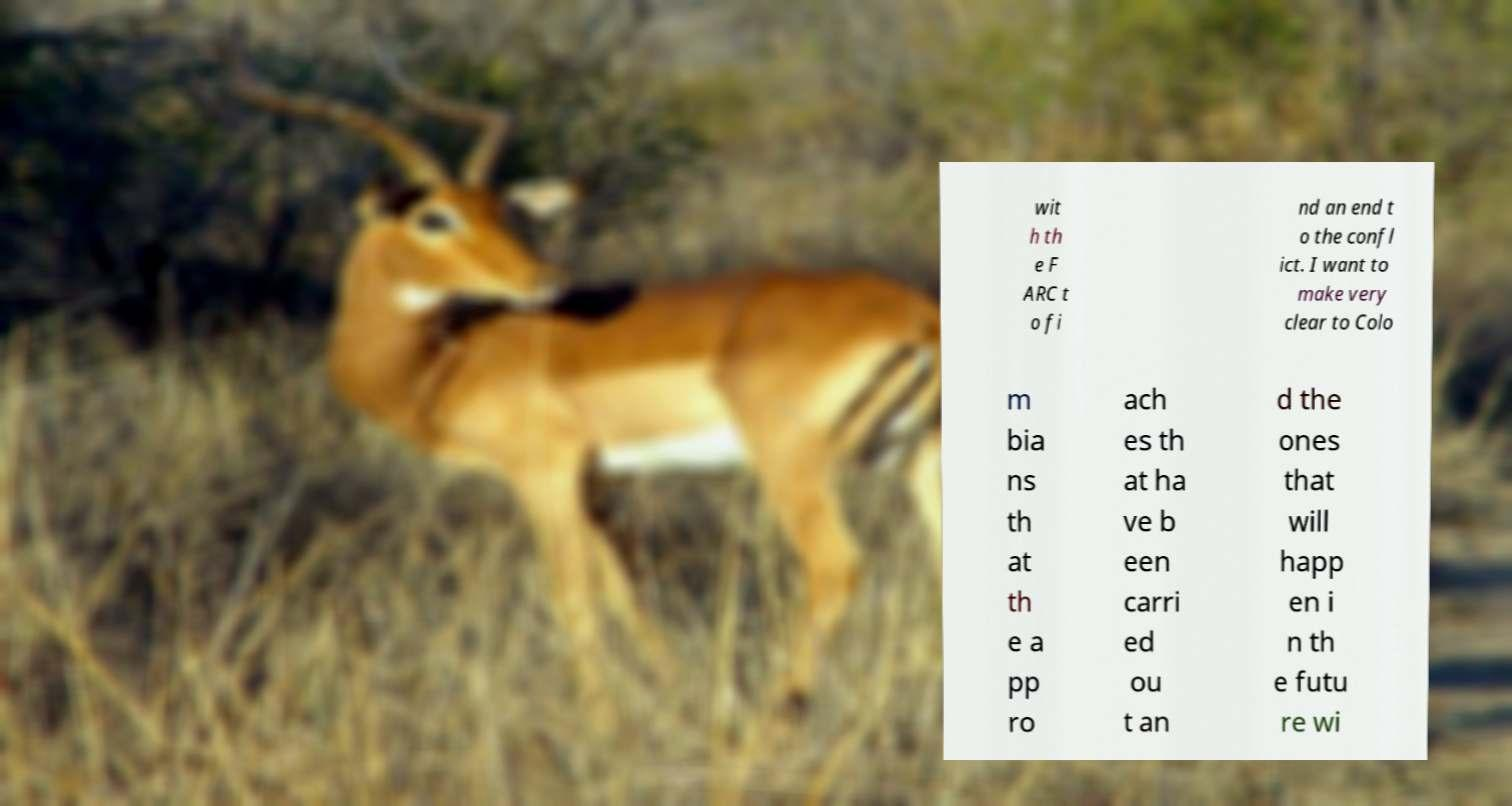Could you extract and type out the text from this image? wit h th e F ARC t o fi nd an end t o the confl ict. I want to make very clear to Colo m bia ns th at th e a pp ro ach es th at ha ve b een carri ed ou t an d the ones that will happ en i n th e futu re wi 